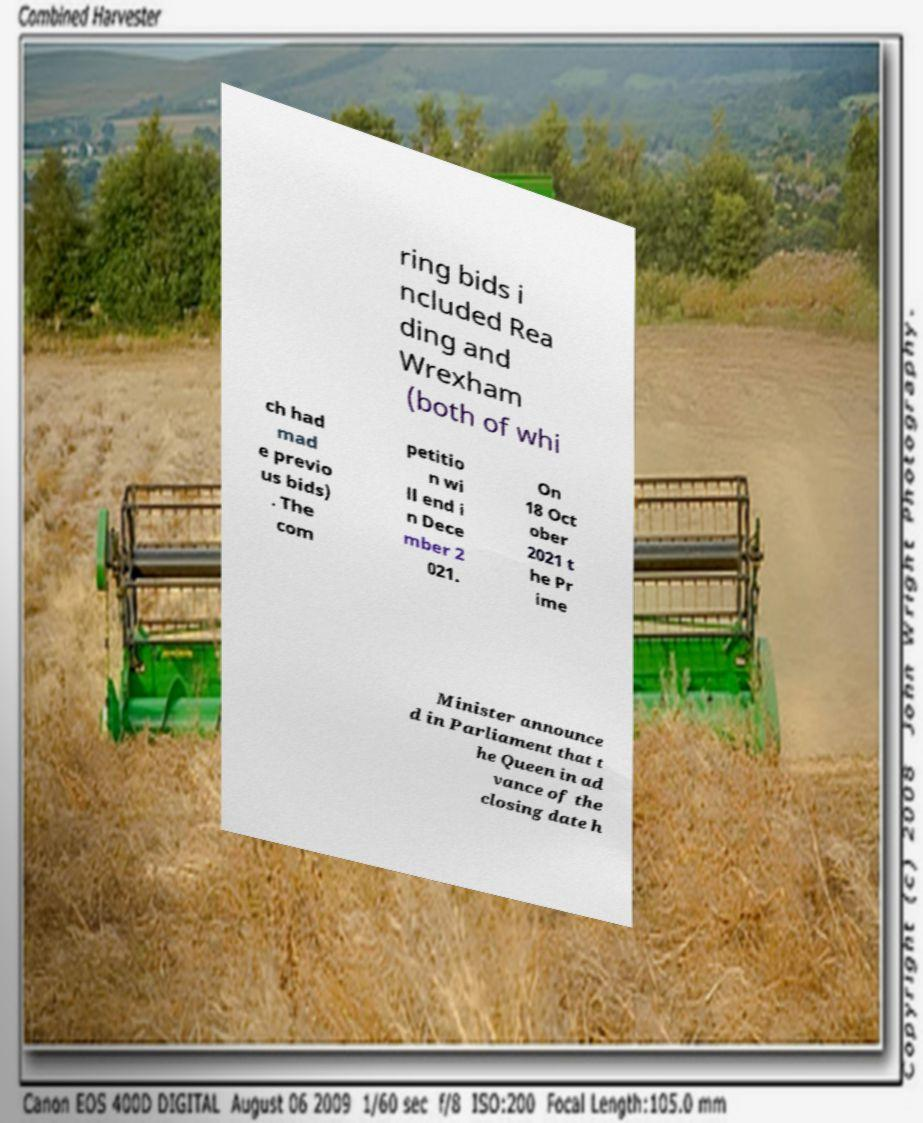Can you read and provide the text displayed in the image?This photo seems to have some interesting text. Can you extract and type it out for me? ring bids i ncluded Rea ding and Wrexham (both of whi ch had mad e previo us bids) . The com petitio n wi ll end i n Dece mber 2 021. On 18 Oct ober 2021 t he Pr ime Minister announce d in Parliament that t he Queen in ad vance of the closing date h 